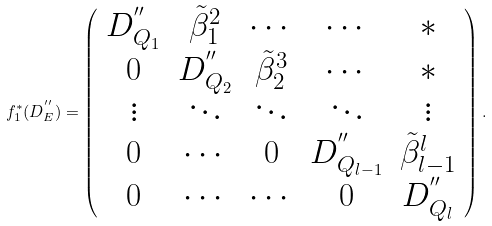Convert formula to latex. <formula><loc_0><loc_0><loc_500><loc_500>f _ { 1 } ^ { * } ( D _ { E } ^ { ^ { \prime \prime } } ) = \left ( \begin{array} { c c c c c } D _ { Q _ { 1 } } ^ { ^ { \prime \prime } } & \tilde { \beta } _ { 1 } ^ { 2 } & \cdots & \cdots & * \\ 0 & D _ { Q _ { 2 } } ^ { ^ { \prime \prime } } & \tilde { \beta } _ { 2 } ^ { 3 } & \cdots & * \\ \vdots & \ddots & \ddots & \ddots & \vdots \\ 0 & \cdots & 0 & D _ { Q _ { l - 1 } } ^ { ^ { \prime \prime } } & \tilde { \beta } _ { l - 1 } ^ { l } \\ 0 & \cdots & \cdots & 0 & D _ { Q _ { l } } ^ { ^ { \prime \prime } } \end{array} \right ) .</formula> 